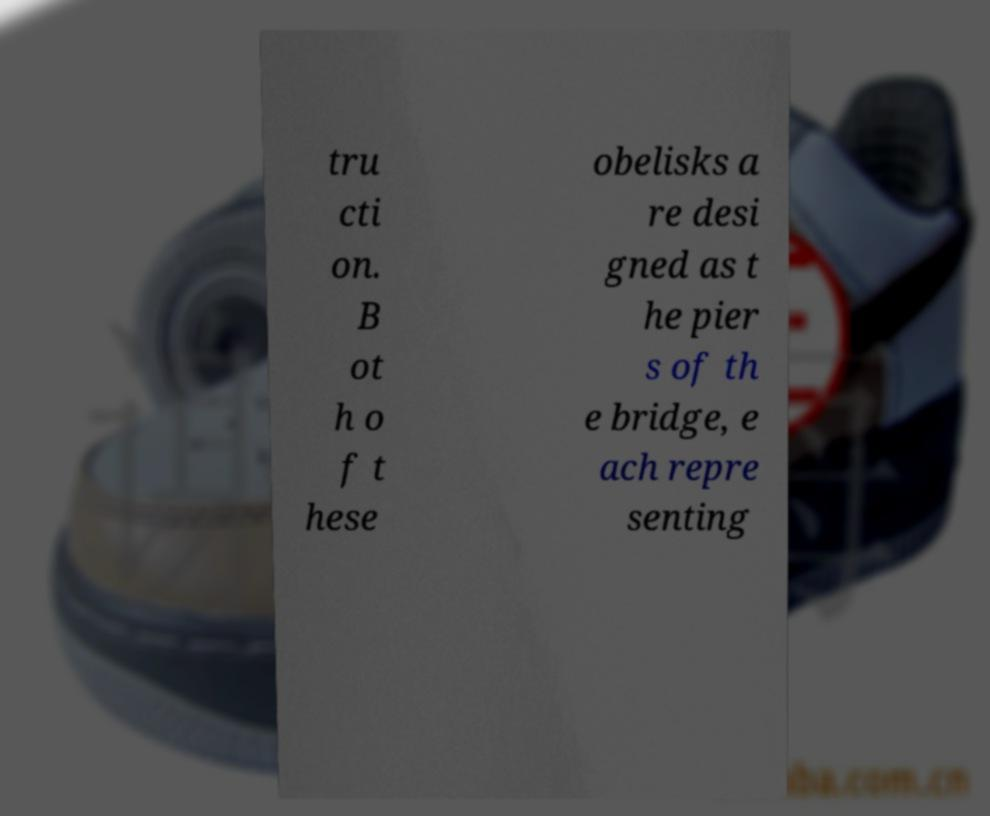For documentation purposes, I need the text within this image transcribed. Could you provide that? tru cti on. B ot h o f t hese obelisks a re desi gned as t he pier s of th e bridge, e ach repre senting 